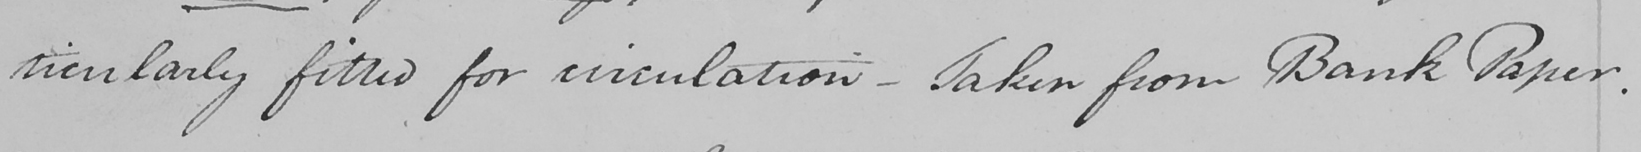What does this handwritten line say? ticularly fitted for circulation  _  Taken from Bank Paper . 